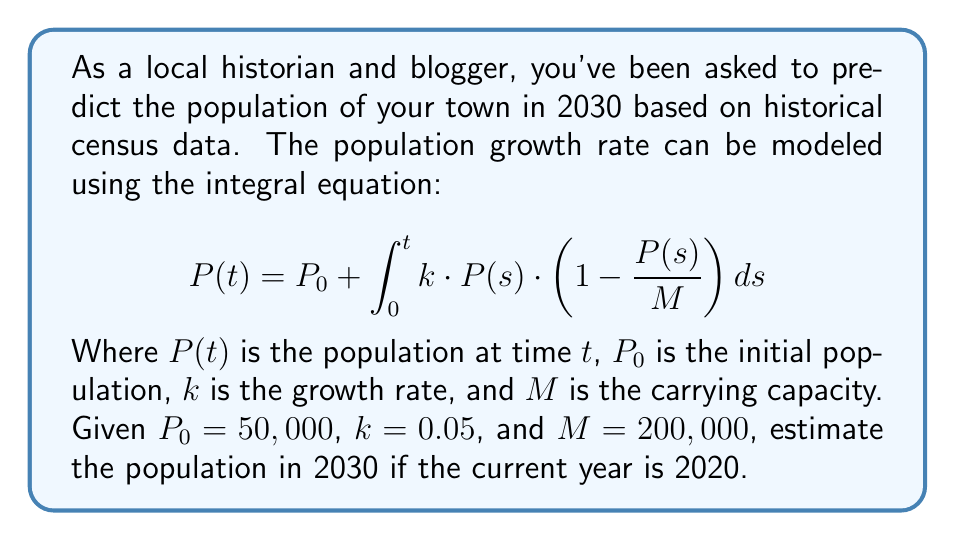Could you help me with this problem? To solve this problem, we need to use numerical methods to approximate the integral equation, as it doesn't have a simple analytical solution. We'll use the Euler method with a step size of 1 year.

1) First, let's set up our initial conditions:
   $t_0 = 0$ (representing 2020)
   $P_0 = 50,000$
   $k = 0.05$
   $M = 200,000$
   $\Delta t = 1$ (step size of 1 year)

2) The Euler method approximation for this integral equation is:
   $$P_{n+1} = P_n + k \cdot P_n \cdot (1 - \frac{P_n}{M}) \cdot \Delta t$$

3) Let's calculate the population for each year:

   For 2021 ($n = 1$):
   $P_1 = 50,000 + 0.05 \cdot 50,000 \cdot (1 - \frac{50,000}{200,000}) \cdot 1 = 51,875$

   For 2022 ($n = 2$):
   $P_2 = 51,875 + 0.05 \cdot 51,875 \cdot (1 - \frac{51,875}{200,000}) \cdot 1 = 53,711$

   For 2023 ($n = 3$):
   $P_3 = 53,711 + 0.05 \cdot 53,711 \cdot (1 - \frac{53,711}{200,000}) \cdot 1 = 55,505$

   ...

   Continuing this process for 10 iterations (until 2030), we get:

4) The estimated population in 2030 is approximately 68,280.

Note: This is a simplified model and actual population growth may be influenced by many other factors not accounted for in this equation.
Answer: 68,280 